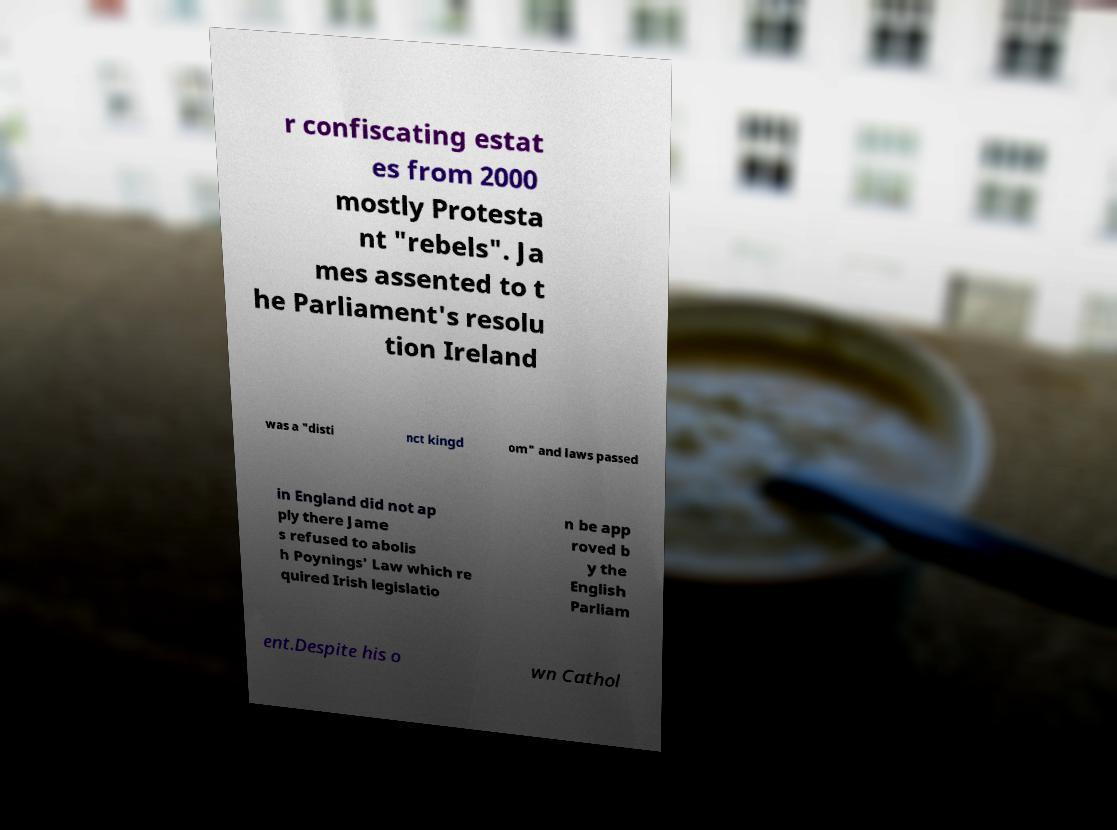Can you accurately transcribe the text from the provided image for me? r confiscating estat es from 2000 mostly Protesta nt "rebels". Ja mes assented to t he Parliament's resolu tion Ireland was a "disti nct kingd om" and laws passed in England did not ap ply there Jame s refused to abolis h Poynings' Law which re quired Irish legislatio n be app roved b y the English Parliam ent.Despite his o wn Cathol 